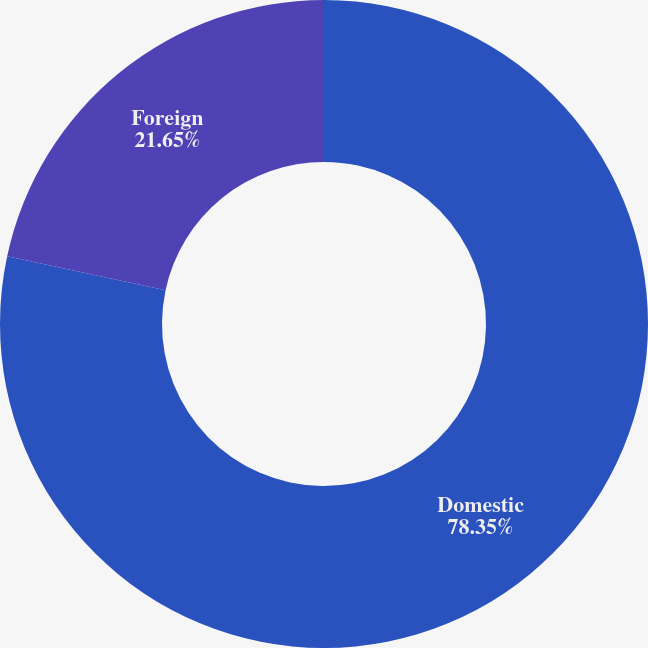<chart> <loc_0><loc_0><loc_500><loc_500><pie_chart><fcel>Domestic<fcel>Foreign<nl><fcel>78.35%<fcel>21.65%<nl></chart> 